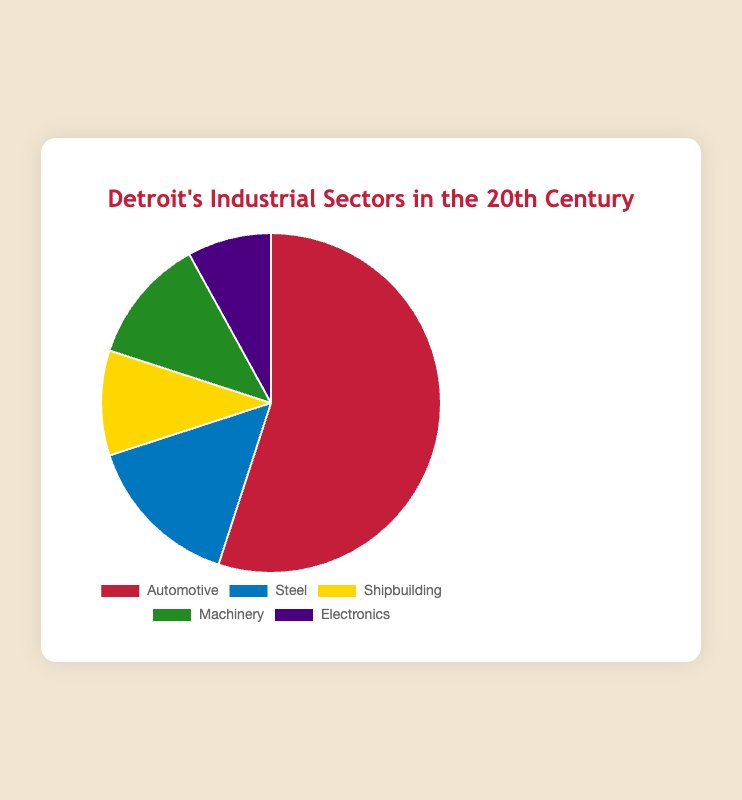Which industry sector has the largest share in Detroit's economy during the 20th century? The largest sector in a pie chart is represented by the largest slice. The Automotive sector has the largest slice, indicating it has the largest share.
Answer: Automotive How much larger is the Automotive sector's share compared to the Machinery sector? Subtract the percentage of the Machinery sector from the Automotive sector. So, 55% - 12% = 43%.
Answer: 43% What is the combined percentage of the Steel and Shipbuilding sectors? Add the percentage of the Steel sector (15%) to the Shipbuilding sector (10%). 15% + 10% = 25%.
Answer: 25% Which sectors together constitute more than half of Detroit's economy during the 20th century? Check sectors whose combined percentages sum to more than 50%. The Automotive sector alone makes up 55%, so it constitutes more than half on its own.
Answer: Automotive Which sector has the smallest share, and what is its percentage? The smallest sector in a pie chart is represented by the smallest slice. The Electronics sector has the smallest slice with 8%.
Answer: Electronics Is the percentage of the Steel sector greater than the sum of the Shipbuilding and Electronics sectors? Calculate the sum of the Shipbuilding and Electronics sectors, 10% + 8% = 18%. Compare with the Steel sector's percentage, 15%. 15% < 18%.
Answer: No If the percentages of all other sectors were halved, would the Automotive sector still be the largest? Halve the percentages of Steel, Shipbuilding, Machinery, and Electronics: Steel 7.5%, Shipbuilding 5%, Machinery 6%, Electronics 4%. The total for these now is 22.5%. The Automotive sector remains 55%, so it is still larger.
Answer: Yes What percentage do Machinery and Electronics sectors contribute together? Add the percentages of the Machinery sector (12%) and Electronics sector (8%). 12% + 8% = 20%.
Answer: 20% Which sector has a percentage that is closest to that of the Machinery sector? Compare the percentages: Automotive (55%), Steel (15%), Shipbuilding (10%), Machinery (12%), Electronics (8%). The closest to 12% is the Steel sector with 15%.
Answer: Steel 